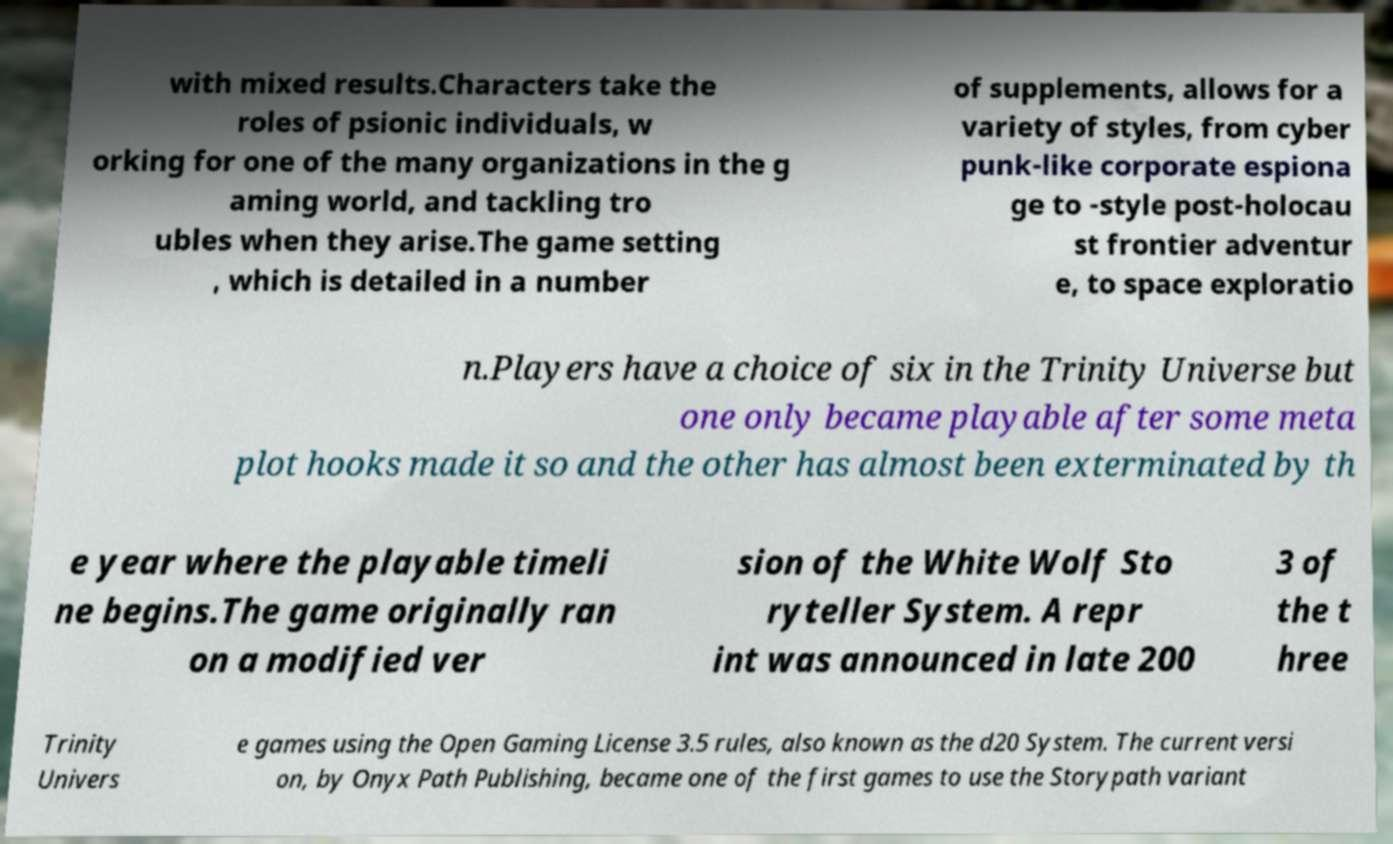There's text embedded in this image that I need extracted. Can you transcribe it verbatim? with mixed results.Characters take the roles of psionic individuals, w orking for one of the many organizations in the g aming world, and tackling tro ubles when they arise.The game setting , which is detailed in a number of supplements, allows for a variety of styles, from cyber punk-like corporate espiona ge to -style post-holocau st frontier adventur e, to space exploratio n.Players have a choice of six in the Trinity Universe but one only became playable after some meta plot hooks made it so and the other has almost been exterminated by th e year where the playable timeli ne begins.The game originally ran on a modified ver sion of the White Wolf Sto ryteller System. A repr int was announced in late 200 3 of the t hree Trinity Univers e games using the Open Gaming License 3.5 rules, also known as the d20 System. The current versi on, by Onyx Path Publishing, became one of the first games to use the Storypath variant 